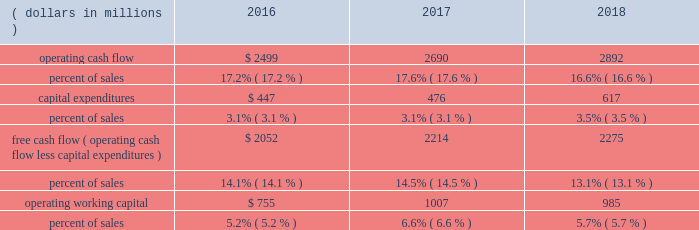24 | 2018 emerson annual report 2017 vs .
2016 2013 commercial & residential solutions sales were $ 5.9 billion in 2017 , an increase of $ 302 million , or 5 percent , reflecting favorable conditions in hvac and refrigeration markets in the u.s. , asia and europe , as well as u.s .
And asian construction markets .
Underlying sales increased 5 percent ( $ 297 million ) on 6 percent higher volume , partially offset by 1 percent lower price .
Foreign currency translation deducted $ 20 million and acquisitions added $ 25 million .
Climate technologies sales were $ 4.2 billion in 2017 , an increase of $ 268 million , or 7 percent .
Global air conditioning sales were solid , led by strength in the u.s .
And asia and robust growth in china partially due to easier comparisons , while sales were up modestly in europe and declined moderately in middle east/africa .
Global refrigeration sales were strong , reflecting robust growth in china on increased adoption of energy- efficient solutions and slight growth in the u.s .
Sensors and solutions had strong growth , while temperature controls was up modestly .
Tools & home products sales were $ 1.6 billion in 2017 , up $ 34 million compared to the prior year .
Professional tools had strong growth on favorable demand from oil and gas customers and in other construction-related markets .
Wet/dry vacuums sales were up moderately as favorable conditions continued in u.s .
Construction markets .
Food waste disposers increased slightly , while the storage business declined moderately .
Overall , underlying sales increased 3 percent in the u.s. , 4 percent in europe and 17 percent in asia ( china up 27 percent ) .
Sales increased 3 percent in latin america and 4 percent in canada , while sales decreased 5 percent in middle east/africa .
Earnings were $ 1.4 billion , an increase of $ 72 million driven by climate technologies , while margin was flat .
Increased volume and resulting leverage , savings from cost reduction actions , and lower customer accommodation costs of $ 16 million were largely offset by higher materials costs , lower price and unfavorable product mix .
Financial position , capital resources and liquidity the company continues to generate substantial cash from operations and has the resources available to reinvest for growth in existing businesses , pursue strategic acquisitions and manage its capital structure on a short- and long-term basis .
Cash flow from continuing operations ( dollars in millions ) 2016 2017 2018 .
Operating cash flow from continuing operations for 2018 was $ 2.9 billion , a $ 202 million , or 8 percent increase compared with 2017 , primarily due to higher earnings , partially offset by an increase in working capital investment to support higher levels of sales activity and income taxes paid on the residential storage divestiture .
Operating cash flow from continuing operations of $ 2.7 billion in 2017 increased 8 percent compared to $ 2.5 billion in 2016 , reflecting higher earnings and favorable changes in working capital .
At september 30 , 2018 , operating working capital as a percent of sales was 5.7 percent compared with 6.6 percent in 2017 and 5.2 percent in 2016 .
The increase in 2017 was due to higher levels of working capital in the acquired valves & controls business .
Operating cash flow from continuing operations funded capital expenditures of $ 617 million , dividends of $ 1.2 billion , and common stock purchases of $ 1.0 billion .
In 2018 , the company repatriated $ 1.4 billion of cash held by non-u.s .
Subsidiaries , which was part of the company 2019s previously announced plans .
These funds along with increased short-term borrowings and divestiture proceeds supported acquisitions of $ 2.2 billion .
Contributions to pension plans were $ 61 million in 2018 , $ 45 million in 2017 and $ 66 million in 2016 .
Capital expenditures related to continuing operations were $ 617 million , $ 476 million and $ 447 million in 2018 , 2017 and 2016 , respectively .
Free cash flow from continuing operations ( operating cash flow less capital expenditures ) was $ 2.3 billion in 2018 , up 3 percent .
Free cash flow was $ 2.2 billion in 2017 , compared with $ 2.1 billion in 2016 .
The company is targeting capital spending of approximately $ 650 million in 2019 .
Net cash paid in connection with acquisitions was $ 2.2 billion , $ 3.0 billion and $ 132 million in 2018 , 2017 and 2016 , respectively .
Proceeds from divestitures not classified as discontinued operations were $ 201 million and $ 39 million in 2018 and 2017 , respectively .
Dividends were $ 1.2 billion ( $ 1.94 per share ) in 2018 , compared with $ 1.2 billion ( $ 1.92 per share ) in 2017 and $ 1.2 billion ( $ 1.90 per share ) in 2016 .
In november 2018 , the board of directors voted to increase the quarterly cash dividend 1 percent , to an annualized rate of $ 1.96 per share .
Purchases of emerson common stock totaled $ 1.0 billion , $ 400 million and $ 601 million in 2018 , 2017 and 2016 , respectively , at average per share prices of $ 66.25 , $ 60.51 and $ 48.11 .
The board of directors authorized the purchase of up to 70 million common shares in november 2015 , and 41.8 million shares remain available for purchase under this authorization .
The company purchased 15.1 million shares in 2018 , 6.6 million shares in 2017 , and 12.5 million shares in 2016 under this authorization and the remainder of the may 2013 authorization. .
To maintain the same percentage of sales capital expenditure in 2019 as in 2018 what will be the sales needed in millions? 
Computations: (650 / 3.5%)
Answer: 18571.42857. 